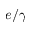<formula> <loc_0><loc_0><loc_500><loc_500>e / \gamma</formula> 